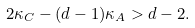<formula> <loc_0><loc_0><loc_500><loc_500>2 \kappa _ { C } - ( d - 1 ) \kappa _ { A } > d - 2 .</formula> 